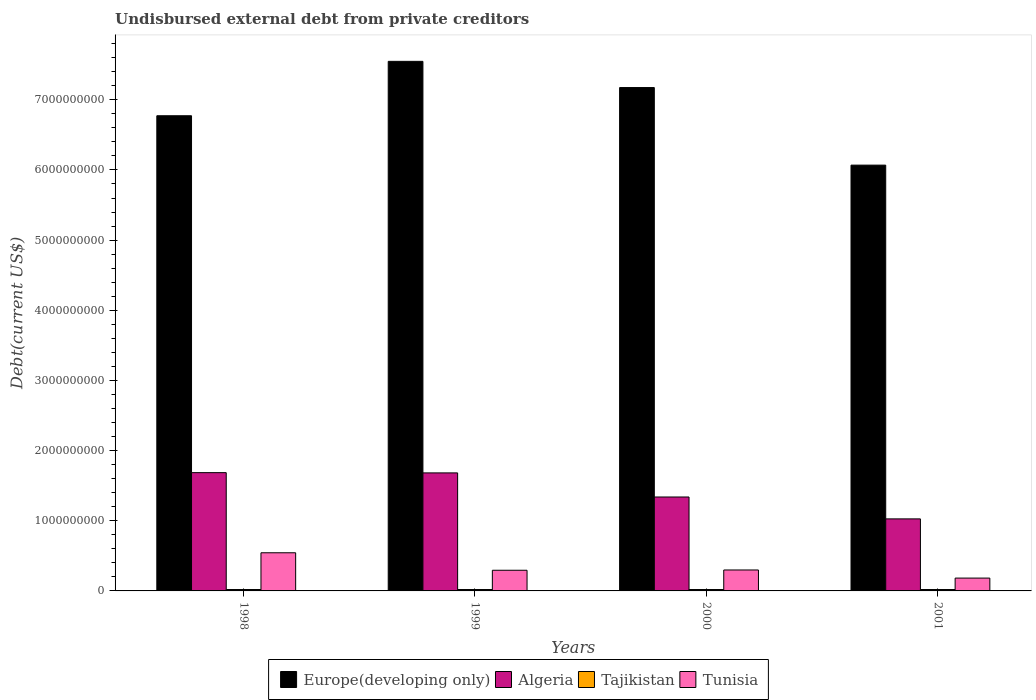Are the number of bars per tick equal to the number of legend labels?
Keep it short and to the point. Yes. Are the number of bars on each tick of the X-axis equal?
Provide a succinct answer. Yes. How many bars are there on the 2nd tick from the left?
Offer a very short reply. 4. In how many cases, is the number of bars for a given year not equal to the number of legend labels?
Your response must be concise. 0. What is the total debt in Europe(developing only) in 2000?
Offer a terse response. 7.17e+09. Across all years, what is the maximum total debt in Tajikistan?
Your response must be concise. 2.00e+07. Across all years, what is the minimum total debt in Tunisia?
Keep it short and to the point. 1.83e+08. In which year was the total debt in Tunisia minimum?
Your answer should be compact. 2001. What is the total total debt in Algeria in the graph?
Your answer should be very brief. 5.73e+09. What is the difference between the total debt in Tunisia in 1998 and that in 2001?
Give a very brief answer. 3.61e+08. What is the difference between the total debt in Europe(developing only) in 2000 and the total debt in Algeria in 2001?
Your answer should be compact. 6.15e+09. What is the average total debt in Tunisia per year?
Offer a very short reply. 3.30e+08. In the year 2001, what is the difference between the total debt in Tunisia and total debt in Tajikistan?
Give a very brief answer. 1.63e+08. In how many years, is the total debt in Europe(developing only) greater than 3400000000 US$?
Offer a very short reply. 4. What is the ratio of the total debt in Algeria in 1998 to that in 2001?
Ensure brevity in your answer.  1.64. What is the difference between the highest and the second highest total debt in Tajikistan?
Offer a terse response. 0. What is the difference between the highest and the lowest total debt in Europe(developing only)?
Offer a terse response. 1.48e+09. What does the 2nd bar from the left in 2001 represents?
Make the answer very short. Algeria. What does the 3rd bar from the right in 1999 represents?
Ensure brevity in your answer.  Algeria. How many bars are there?
Provide a succinct answer. 16. How many years are there in the graph?
Give a very brief answer. 4. What is the difference between two consecutive major ticks on the Y-axis?
Your response must be concise. 1.00e+09. Where does the legend appear in the graph?
Keep it short and to the point. Bottom center. What is the title of the graph?
Your response must be concise. Undisbursed external debt from private creditors. Does "Pacific island small states" appear as one of the legend labels in the graph?
Offer a very short reply. No. What is the label or title of the Y-axis?
Your answer should be compact. Debt(current US$). What is the Debt(current US$) in Europe(developing only) in 1998?
Keep it short and to the point. 6.77e+09. What is the Debt(current US$) in Algeria in 1998?
Offer a very short reply. 1.69e+09. What is the Debt(current US$) in Tajikistan in 1998?
Keep it short and to the point. 2.00e+07. What is the Debt(current US$) in Tunisia in 1998?
Your answer should be very brief. 5.44e+08. What is the Debt(current US$) in Europe(developing only) in 1999?
Make the answer very short. 7.55e+09. What is the Debt(current US$) in Algeria in 1999?
Your response must be concise. 1.68e+09. What is the Debt(current US$) in Tunisia in 1999?
Your answer should be very brief. 2.95e+08. What is the Debt(current US$) of Europe(developing only) in 2000?
Provide a short and direct response. 7.17e+09. What is the Debt(current US$) of Algeria in 2000?
Make the answer very short. 1.34e+09. What is the Debt(current US$) of Tunisia in 2000?
Give a very brief answer. 2.99e+08. What is the Debt(current US$) in Europe(developing only) in 2001?
Provide a succinct answer. 6.07e+09. What is the Debt(current US$) in Algeria in 2001?
Provide a short and direct response. 1.03e+09. What is the Debt(current US$) in Tunisia in 2001?
Your answer should be compact. 1.83e+08. Across all years, what is the maximum Debt(current US$) in Europe(developing only)?
Give a very brief answer. 7.55e+09. Across all years, what is the maximum Debt(current US$) in Algeria?
Make the answer very short. 1.69e+09. Across all years, what is the maximum Debt(current US$) of Tunisia?
Offer a terse response. 5.44e+08. Across all years, what is the minimum Debt(current US$) of Europe(developing only)?
Give a very brief answer. 6.07e+09. Across all years, what is the minimum Debt(current US$) in Algeria?
Your answer should be compact. 1.03e+09. Across all years, what is the minimum Debt(current US$) in Tunisia?
Offer a terse response. 1.83e+08. What is the total Debt(current US$) of Europe(developing only) in the graph?
Give a very brief answer. 2.76e+1. What is the total Debt(current US$) of Algeria in the graph?
Your answer should be very brief. 5.73e+09. What is the total Debt(current US$) of Tajikistan in the graph?
Ensure brevity in your answer.  8.00e+07. What is the total Debt(current US$) in Tunisia in the graph?
Your answer should be very brief. 1.32e+09. What is the difference between the Debt(current US$) in Europe(developing only) in 1998 and that in 1999?
Provide a short and direct response. -7.75e+08. What is the difference between the Debt(current US$) of Algeria in 1998 and that in 1999?
Provide a short and direct response. 3.66e+06. What is the difference between the Debt(current US$) of Tunisia in 1998 and that in 1999?
Your response must be concise. 2.49e+08. What is the difference between the Debt(current US$) in Europe(developing only) in 1998 and that in 2000?
Offer a terse response. -4.02e+08. What is the difference between the Debt(current US$) in Algeria in 1998 and that in 2000?
Make the answer very short. 3.47e+08. What is the difference between the Debt(current US$) in Tunisia in 1998 and that in 2000?
Keep it short and to the point. 2.45e+08. What is the difference between the Debt(current US$) in Europe(developing only) in 1998 and that in 2001?
Offer a very short reply. 7.04e+08. What is the difference between the Debt(current US$) in Algeria in 1998 and that in 2001?
Offer a terse response. 6.59e+08. What is the difference between the Debt(current US$) of Tunisia in 1998 and that in 2001?
Keep it short and to the point. 3.61e+08. What is the difference between the Debt(current US$) in Europe(developing only) in 1999 and that in 2000?
Keep it short and to the point. 3.73e+08. What is the difference between the Debt(current US$) in Algeria in 1999 and that in 2000?
Your answer should be very brief. 3.43e+08. What is the difference between the Debt(current US$) in Tajikistan in 1999 and that in 2000?
Give a very brief answer. 0. What is the difference between the Debt(current US$) in Tunisia in 1999 and that in 2000?
Your response must be concise. -3.97e+06. What is the difference between the Debt(current US$) in Europe(developing only) in 1999 and that in 2001?
Make the answer very short. 1.48e+09. What is the difference between the Debt(current US$) in Algeria in 1999 and that in 2001?
Provide a short and direct response. 6.55e+08. What is the difference between the Debt(current US$) in Tunisia in 1999 and that in 2001?
Give a very brief answer. 1.12e+08. What is the difference between the Debt(current US$) of Europe(developing only) in 2000 and that in 2001?
Offer a terse response. 1.11e+09. What is the difference between the Debt(current US$) of Algeria in 2000 and that in 2001?
Ensure brevity in your answer.  3.12e+08. What is the difference between the Debt(current US$) of Tunisia in 2000 and that in 2001?
Make the answer very short. 1.16e+08. What is the difference between the Debt(current US$) in Europe(developing only) in 1998 and the Debt(current US$) in Algeria in 1999?
Your answer should be compact. 5.09e+09. What is the difference between the Debt(current US$) of Europe(developing only) in 1998 and the Debt(current US$) of Tajikistan in 1999?
Give a very brief answer. 6.75e+09. What is the difference between the Debt(current US$) in Europe(developing only) in 1998 and the Debt(current US$) in Tunisia in 1999?
Offer a terse response. 6.48e+09. What is the difference between the Debt(current US$) in Algeria in 1998 and the Debt(current US$) in Tajikistan in 1999?
Make the answer very short. 1.67e+09. What is the difference between the Debt(current US$) of Algeria in 1998 and the Debt(current US$) of Tunisia in 1999?
Offer a terse response. 1.39e+09. What is the difference between the Debt(current US$) of Tajikistan in 1998 and the Debt(current US$) of Tunisia in 1999?
Your answer should be very brief. -2.75e+08. What is the difference between the Debt(current US$) in Europe(developing only) in 1998 and the Debt(current US$) in Algeria in 2000?
Offer a terse response. 5.43e+09. What is the difference between the Debt(current US$) in Europe(developing only) in 1998 and the Debt(current US$) in Tajikistan in 2000?
Provide a succinct answer. 6.75e+09. What is the difference between the Debt(current US$) in Europe(developing only) in 1998 and the Debt(current US$) in Tunisia in 2000?
Keep it short and to the point. 6.47e+09. What is the difference between the Debt(current US$) in Algeria in 1998 and the Debt(current US$) in Tajikistan in 2000?
Make the answer very short. 1.67e+09. What is the difference between the Debt(current US$) in Algeria in 1998 and the Debt(current US$) in Tunisia in 2000?
Provide a succinct answer. 1.39e+09. What is the difference between the Debt(current US$) in Tajikistan in 1998 and the Debt(current US$) in Tunisia in 2000?
Make the answer very short. -2.79e+08. What is the difference between the Debt(current US$) in Europe(developing only) in 1998 and the Debt(current US$) in Algeria in 2001?
Offer a terse response. 5.75e+09. What is the difference between the Debt(current US$) in Europe(developing only) in 1998 and the Debt(current US$) in Tajikistan in 2001?
Your answer should be compact. 6.75e+09. What is the difference between the Debt(current US$) in Europe(developing only) in 1998 and the Debt(current US$) in Tunisia in 2001?
Offer a terse response. 6.59e+09. What is the difference between the Debt(current US$) of Algeria in 1998 and the Debt(current US$) of Tajikistan in 2001?
Provide a succinct answer. 1.67e+09. What is the difference between the Debt(current US$) of Algeria in 1998 and the Debt(current US$) of Tunisia in 2001?
Give a very brief answer. 1.50e+09. What is the difference between the Debt(current US$) in Tajikistan in 1998 and the Debt(current US$) in Tunisia in 2001?
Ensure brevity in your answer.  -1.63e+08. What is the difference between the Debt(current US$) in Europe(developing only) in 1999 and the Debt(current US$) in Algeria in 2000?
Provide a short and direct response. 6.21e+09. What is the difference between the Debt(current US$) in Europe(developing only) in 1999 and the Debt(current US$) in Tajikistan in 2000?
Provide a succinct answer. 7.53e+09. What is the difference between the Debt(current US$) in Europe(developing only) in 1999 and the Debt(current US$) in Tunisia in 2000?
Your response must be concise. 7.25e+09. What is the difference between the Debt(current US$) in Algeria in 1999 and the Debt(current US$) in Tajikistan in 2000?
Provide a short and direct response. 1.66e+09. What is the difference between the Debt(current US$) in Algeria in 1999 and the Debt(current US$) in Tunisia in 2000?
Give a very brief answer. 1.38e+09. What is the difference between the Debt(current US$) in Tajikistan in 1999 and the Debt(current US$) in Tunisia in 2000?
Give a very brief answer. -2.79e+08. What is the difference between the Debt(current US$) of Europe(developing only) in 1999 and the Debt(current US$) of Algeria in 2001?
Offer a terse response. 6.52e+09. What is the difference between the Debt(current US$) of Europe(developing only) in 1999 and the Debt(current US$) of Tajikistan in 2001?
Ensure brevity in your answer.  7.53e+09. What is the difference between the Debt(current US$) of Europe(developing only) in 1999 and the Debt(current US$) of Tunisia in 2001?
Provide a short and direct response. 7.37e+09. What is the difference between the Debt(current US$) of Algeria in 1999 and the Debt(current US$) of Tajikistan in 2001?
Provide a short and direct response. 1.66e+09. What is the difference between the Debt(current US$) in Algeria in 1999 and the Debt(current US$) in Tunisia in 2001?
Offer a terse response. 1.50e+09. What is the difference between the Debt(current US$) in Tajikistan in 1999 and the Debt(current US$) in Tunisia in 2001?
Offer a very short reply. -1.63e+08. What is the difference between the Debt(current US$) of Europe(developing only) in 2000 and the Debt(current US$) of Algeria in 2001?
Provide a succinct answer. 6.15e+09. What is the difference between the Debt(current US$) in Europe(developing only) in 2000 and the Debt(current US$) in Tajikistan in 2001?
Provide a short and direct response. 7.15e+09. What is the difference between the Debt(current US$) of Europe(developing only) in 2000 and the Debt(current US$) of Tunisia in 2001?
Your answer should be compact. 6.99e+09. What is the difference between the Debt(current US$) of Algeria in 2000 and the Debt(current US$) of Tajikistan in 2001?
Offer a very short reply. 1.32e+09. What is the difference between the Debt(current US$) in Algeria in 2000 and the Debt(current US$) in Tunisia in 2001?
Your answer should be compact. 1.16e+09. What is the difference between the Debt(current US$) of Tajikistan in 2000 and the Debt(current US$) of Tunisia in 2001?
Ensure brevity in your answer.  -1.63e+08. What is the average Debt(current US$) in Europe(developing only) per year?
Your response must be concise. 6.89e+09. What is the average Debt(current US$) in Algeria per year?
Offer a very short reply. 1.43e+09. What is the average Debt(current US$) in Tajikistan per year?
Provide a succinct answer. 2.00e+07. What is the average Debt(current US$) of Tunisia per year?
Your answer should be compact. 3.30e+08. In the year 1998, what is the difference between the Debt(current US$) of Europe(developing only) and Debt(current US$) of Algeria?
Your response must be concise. 5.09e+09. In the year 1998, what is the difference between the Debt(current US$) in Europe(developing only) and Debt(current US$) in Tajikistan?
Make the answer very short. 6.75e+09. In the year 1998, what is the difference between the Debt(current US$) of Europe(developing only) and Debt(current US$) of Tunisia?
Make the answer very short. 6.23e+09. In the year 1998, what is the difference between the Debt(current US$) in Algeria and Debt(current US$) in Tajikistan?
Your answer should be very brief. 1.67e+09. In the year 1998, what is the difference between the Debt(current US$) of Algeria and Debt(current US$) of Tunisia?
Give a very brief answer. 1.14e+09. In the year 1998, what is the difference between the Debt(current US$) of Tajikistan and Debt(current US$) of Tunisia?
Keep it short and to the point. -5.24e+08. In the year 1999, what is the difference between the Debt(current US$) of Europe(developing only) and Debt(current US$) of Algeria?
Provide a short and direct response. 5.87e+09. In the year 1999, what is the difference between the Debt(current US$) of Europe(developing only) and Debt(current US$) of Tajikistan?
Give a very brief answer. 7.53e+09. In the year 1999, what is the difference between the Debt(current US$) in Europe(developing only) and Debt(current US$) in Tunisia?
Ensure brevity in your answer.  7.25e+09. In the year 1999, what is the difference between the Debt(current US$) in Algeria and Debt(current US$) in Tajikistan?
Your answer should be very brief. 1.66e+09. In the year 1999, what is the difference between the Debt(current US$) of Algeria and Debt(current US$) of Tunisia?
Ensure brevity in your answer.  1.39e+09. In the year 1999, what is the difference between the Debt(current US$) of Tajikistan and Debt(current US$) of Tunisia?
Your answer should be very brief. -2.75e+08. In the year 2000, what is the difference between the Debt(current US$) of Europe(developing only) and Debt(current US$) of Algeria?
Give a very brief answer. 5.84e+09. In the year 2000, what is the difference between the Debt(current US$) in Europe(developing only) and Debt(current US$) in Tajikistan?
Your response must be concise. 7.15e+09. In the year 2000, what is the difference between the Debt(current US$) of Europe(developing only) and Debt(current US$) of Tunisia?
Ensure brevity in your answer.  6.88e+09. In the year 2000, what is the difference between the Debt(current US$) in Algeria and Debt(current US$) in Tajikistan?
Give a very brief answer. 1.32e+09. In the year 2000, what is the difference between the Debt(current US$) of Algeria and Debt(current US$) of Tunisia?
Offer a terse response. 1.04e+09. In the year 2000, what is the difference between the Debt(current US$) in Tajikistan and Debt(current US$) in Tunisia?
Provide a succinct answer. -2.79e+08. In the year 2001, what is the difference between the Debt(current US$) of Europe(developing only) and Debt(current US$) of Algeria?
Your answer should be very brief. 5.04e+09. In the year 2001, what is the difference between the Debt(current US$) in Europe(developing only) and Debt(current US$) in Tajikistan?
Provide a succinct answer. 6.05e+09. In the year 2001, what is the difference between the Debt(current US$) of Europe(developing only) and Debt(current US$) of Tunisia?
Make the answer very short. 5.89e+09. In the year 2001, what is the difference between the Debt(current US$) of Algeria and Debt(current US$) of Tajikistan?
Give a very brief answer. 1.01e+09. In the year 2001, what is the difference between the Debt(current US$) of Algeria and Debt(current US$) of Tunisia?
Offer a very short reply. 8.44e+08. In the year 2001, what is the difference between the Debt(current US$) in Tajikistan and Debt(current US$) in Tunisia?
Offer a terse response. -1.63e+08. What is the ratio of the Debt(current US$) of Europe(developing only) in 1998 to that in 1999?
Ensure brevity in your answer.  0.9. What is the ratio of the Debt(current US$) of Algeria in 1998 to that in 1999?
Your answer should be compact. 1. What is the ratio of the Debt(current US$) of Tajikistan in 1998 to that in 1999?
Ensure brevity in your answer.  1. What is the ratio of the Debt(current US$) of Tunisia in 1998 to that in 1999?
Your response must be concise. 1.85. What is the ratio of the Debt(current US$) in Europe(developing only) in 1998 to that in 2000?
Give a very brief answer. 0.94. What is the ratio of the Debt(current US$) of Algeria in 1998 to that in 2000?
Offer a very short reply. 1.26. What is the ratio of the Debt(current US$) in Tajikistan in 1998 to that in 2000?
Provide a short and direct response. 1. What is the ratio of the Debt(current US$) of Tunisia in 1998 to that in 2000?
Provide a succinct answer. 1.82. What is the ratio of the Debt(current US$) of Europe(developing only) in 1998 to that in 2001?
Offer a very short reply. 1.12. What is the ratio of the Debt(current US$) in Algeria in 1998 to that in 2001?
Offer a very short reply. 1.64. What is the ratio of the Debt(current US$) in Tunisia in 1998 to that in 2001?
Your answer should be very brief. 2.97. What is the ratio of the Debt(current US$) of Europe(developing only) in 1999 to that in 2000?
Provide a short and direct response. 1.05. What is the ratio of the Debt(current US$) in Algeria in 1999 to that in 2000?
Your response must be concise. 1.26. What is the ratio of the Debt(current US$) of Tajikistan in 1999 to that in 2000?
Ensure brevity in your answer.  1. What is the ratio of the Debt(current US$) of Tunisia in 1999 to that in 2000?
Provide a short and direct response. 0.99. What is the ratio of the Debt(current US$) in Europe(developing only) in 1999 to that in 2001?
Your answer should be very brief. 1.24. What is the ratio of the Debt(current US$) of Algeria in 1999 to that in 2001?
Provide a succinct answer. 1.64. What is the ratio of the Debt(current US$) of Tunisia in 1999 to that in 2001?
Your response must be concise. 1.61. What is the ratio of the Debt(current US$) in Europe(developing only) in 2000 to that in 2001?
Give a very brief answer. 1.18. What is the ratio of the Debt(current US$) of Algeria in 2000 to that in 2001?
Keep it short and to the point. 1.3. What is the ratio of the Debt(current US$) in Tajikistan in 2000 to that in 2001?
Give a very brief answer. 1. What is the ratio of the Debt(current US$) in Tunisia in 2000 to that in 2001?
Provide a succinct answer. 1.63. What is the difference between the highest and the second highest Debt(current US$) in Europe(developing only)?
Give a very brief answer. 3.73e+08. What is the difference between the highest and the second highest Debt(current US$) in Algeria?
Your response must be concise. 3.66e+06. What is the difference between the highest and the second highest Debt(current US$) of Tajikistan?
Ensure brevity in your answer.  0. What is the difference between the highest and the second highest Debt(current US$) in Tunisia?
Ensure brevity in your answer.  2.45e+08. What is the difference between the highest and the lowest Debt(current US$) of Europe(developing only)?
Provide a succinct answer. 1.48e+09. What is the difference between the highest and the lowest Debt(current US$) in Algeria?
Offer a very short reply. 6.59e+08. What is the difference between the highest and the lowest Debt(current US$) in Tunisia?
Your answer should be very brief. 3.61e+08. 